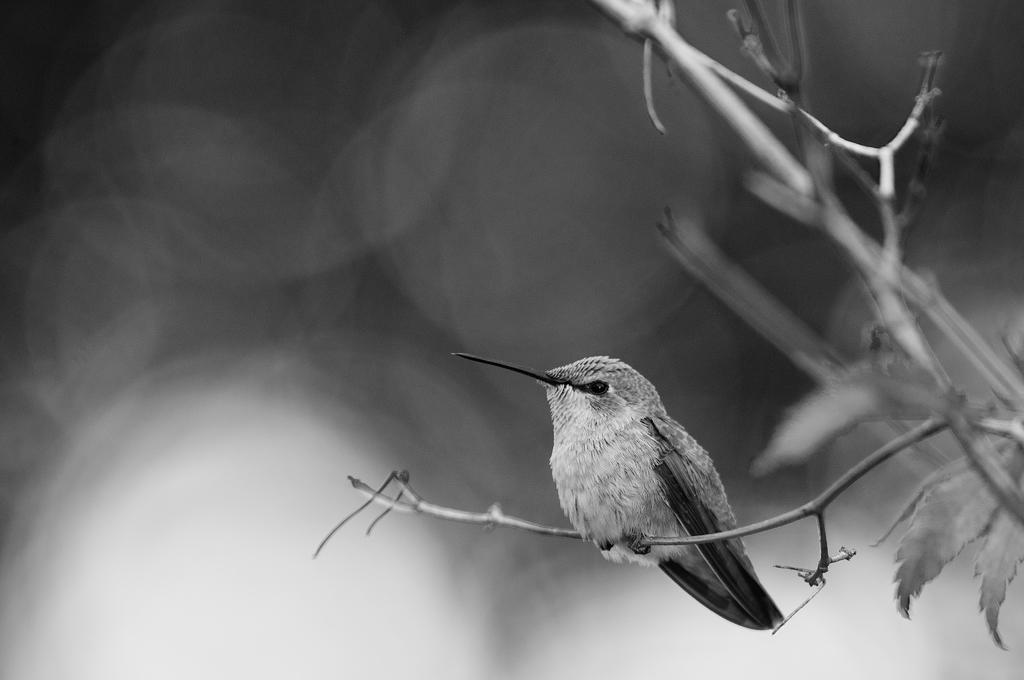Please provide a concise description of this image. In this picture we can observe a bird on the small plant. We can observe a sharp peak to this bird. The background is completely blurred. This is a black and white image. 